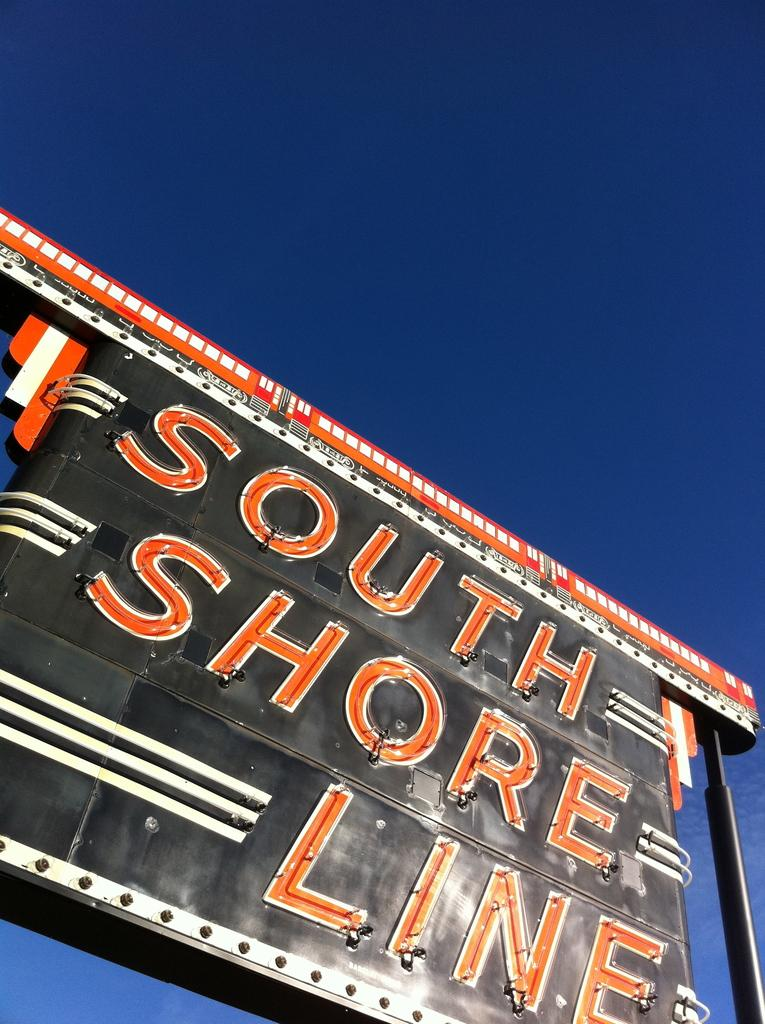<image>
Summarize the visual content of the image. A south Shore Line sign is orange, black, and white. 